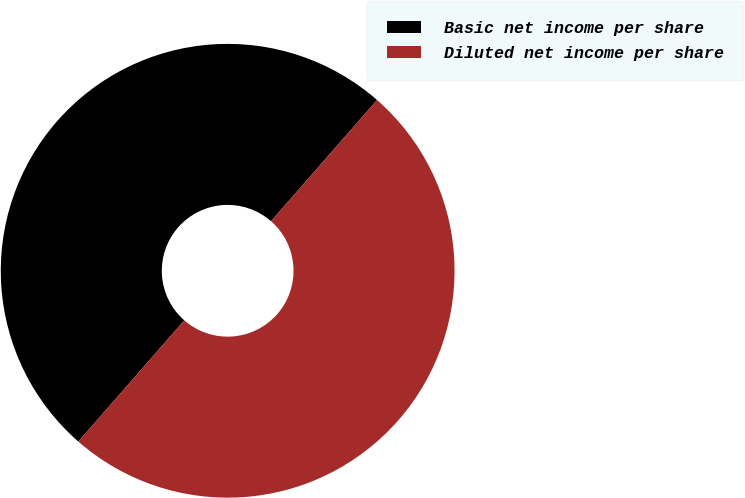Convert chart. <chart><loc_0><loc_0><loc_500><loc_500><pie_chart><fcel>Basic net income per share<fcel>Diluted net income per share<nl><fcel>50.0%<fcel>50.0%<nl></chart> 